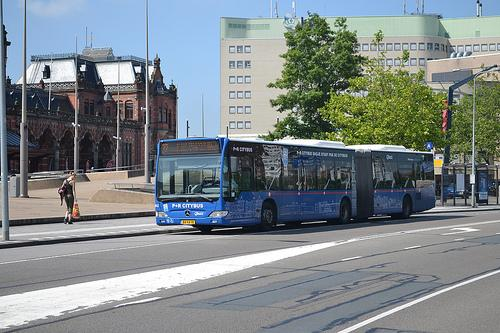What type of transportation is displayed in the image and discuss any notable features it has. A blue public bus with distinctive orange letters, numbers, and a yellow license plate on it is on the street. Give a concise overview of the entire scene captured in the image. The image features a blue bus on a street, a woman walking with an orange bag, and a red building nearby. Describe the main vehicle in the image along with its unique features. The main vehicle is a blue city bus that has orange letters and numbers, and a yellow license plate. Explain the color and type of the most prominent vehicle in the picture. The most prominent vehicle is a blue public bus with orange text and a yellow license plate. Narrate what the woman in the image is doing and her appearance. A woman is walking on the side of the road, wearing high heels and holding a large orange bag. Provide a brief description of the primary object in the image. A blue public bus is on the street with orange letters and numbers, and a yellow license plate. Tell me about the bus in the image, its colors, and what's written on it. The bus is blue with orange letters and numbers, as well as a yellow license plate on the back. Identify the primary mode of transportation in the image and any other activities occurring. The main transportation is a blue public bus, with people walking and carrying bags on the side of the road. Mention the activity taking place within the scene and the key elements present. A blue city bus is parked on a street, with a person walking on the side of the road carrying an orange bag. Briefly describe the environment surrounding the main subject in the image. A blue bus on the street, with a red building, green trees, a woman walking, and a lamppost nearby. 